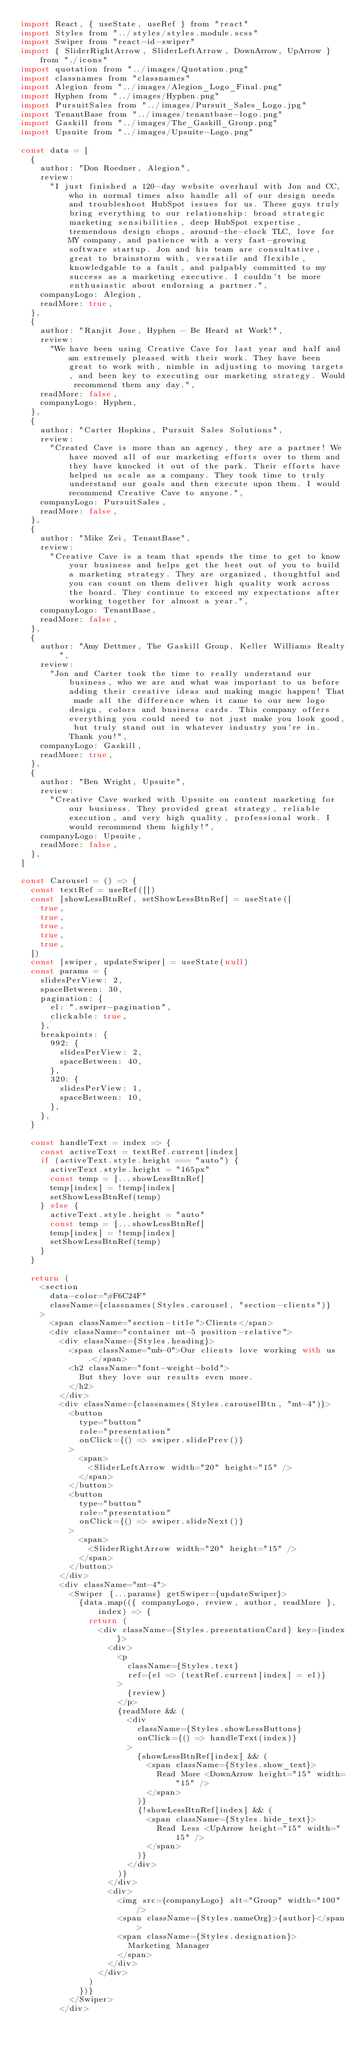<code> <loc_0><loc_0><loc_500><loc_500><_JavaScript_>import React, { useState, useRef } from "react"
import Styles from "../styles/styles.module.scss"
import Swiper from "react-id-swiper"
import { SliderRightArrow, SliderLeftArrow, DownArrow, UpArrow } from "./icons"
import quotation from "../images/Quotation.png"
import classnames from "classnames"
import Alegion from "../images/Alegion_Logo_Final.png"
import Hyphen from "../images/Hyphen.png"
import PursuitSales from "../images/Pursuit_Sales_Logo.jpg"
import TenantBase from "../images/tenantbase-logo.png"
import Gaskill from "../images/The_Gaskill_Group.png"
import Upsuite from "../images/Upsuite-Logo.png"

const data = [
  {
    author: "Don Roedner, Alegion",
    review:
      "I just finished a 120-day website overhaul with Jon and CC, who in normal times also handle all of our design needs and troubleshoot HubSpot issues for us. These guys truly bring everything to our relationship: broad strategic marketing sensibilities, deep HubSpot expertise, tremendous design chops, around-the-clock TLC, love for MY company, and patience with a very fast-growing software startup. Jon and his team are consultative, great to brainstorm with, versatile and flexible, knowledgable to a fault, and palpably committed to my success as a marketing executive. I couldn't be more enthusiastic about endorsing a partner.",
    companyLogo: Alegion,
    readMore: true,
  },
  {
    author: "Ranjit Jose, Hyphen - Be Heard at Work!",
    review:
      "We have been using Creative Cave for last year and half and am extremely pleased with their work. They have been great to work with, nimble in adjusting to moving targets, and been key to executing our marketing strategy. Would recommend them any day.",
    readMore: false,
    companyLogo: Hyphen,
  },
  {
    author: "Carter Hopkins, Pursuit Sales Solutions",
    review:
      "Created Cave is more than an agency, they are a partner! We have moved all of our marketing efforts over to them and they have knocked it out of the park. Their efforts have helped us scale as a company. They took time to truly understand our goals and then execute upon them. I would recommend Creative Cave to anyone.",
    companyLogo: PursuitSales,
    readMore: false,
  },
  {
    author: "Mike Zei, TenantBase",
    review:
      "Creative Cave is a team that spends the time to get to know your business and helps get the best out of you to build a marketing strategy. They are organized, thoughtful and you can count on them deliver high quality work across the board. They continue to exceed my expectations after working together for almost a year.",
    companyLogo: TenantBase,
    readMore: false,
  },
  {
    author: "Amy Dettmer, The Gaskill Group, Keller Williams Realty",
    review:
      "Jon and Carter took the time to really understand our business, who we are and what was important to us before adding their creative ideas and making magic happen! That made all the difference when it came to our new logo design, colors and business cards. This company offers everything you could need to not just make you look good, but truly stand out in whatever industry you're in. Thank you!",
    companyLogo: Gaskill,
    readMore: true,
  },
  {
    author: "Ben Wright, Upsuite",
    review:
      "Creative Cave worked with Upsuite on content marketing for our business. They provided great strategy, reliable execution, and very high quality, professional work. I would recommend them highly!",
    companyLogo: Upsuite,
    readMore: false,
  },
]

const Carousel = () => {
  const textRef = useRef([])
  const [showLessBtnRef, setShowLessBtnRef] = useState([
    true,
    true,
    true,
    true,
    true,
  ])
  const [swiper, updateSwiper] = useState(null)
  const params = {
    slidesPerView: 2,
    spaceBetween: 30,
    pagination: {
      el: ".swiper-pagination",
      clickable: true,
    },
    breakpoints: {
      992: {
        slidesPerView: 2,
        spaceBetween: 40,
      },
      320: {
        slidesPerView: 1,
        spaceBetween: 10,
      },
    },
  }

  const handleText = index => {
    const activeText = textRef.current[index]
    if (activeText.style.height === "auto") {
      activeText.style.height = "165px"
      const temp = [...showLessBtnRef]
      temp[index] = !temp[index]
      setShowLessBtnRef(temp)
    } else {
      activeText.style.height = "auto"
      const temp = [...showLessBtnRef]
      temp[index] = !temp[index]
      setShowLessBtnRef(temp)
    }
  }

  return (
    <section
      data-color="#F6C24F"
      className={classnames(Styles.carousel, "section-clients")}
    >
      <span className="section-title">Clients</span>
      <div className="container mt-5 position-relative">
        <div className={Styles.heading}>
          <span className="mb-0">Our clients love working with us.</span>
          <h2 className="font-weight-bold">
            But they love our results even more.
          </h2>
        </div>
        <div className={classnames(Styles.carouselBtn, "mt-4")}>
          <button
            type="button"
            role="presentation"
            onClick={() => swiper.slidePrev()}
          >
            <span>
              <SliderLeftArrow width="20" height="15" />
            </span>
          </button>
          <button
            type="button"
            role="presentation"
            onClick={() => swiper.slideNext()}
          >
            <span>
              <SliderRightArrow width="20" height="15" />
            </span>
          </button>
        </div>
        <div className="mt-4">
          <Swiper {...params} getSwiper={updateSwiper}>
            {data.map(({ companyLogo, review, author, readMore }, index) => {
              return (
                <div className={Styles.presentationCard} key={index}>
                  <div>
                    <p
                      className={Styles.text}
                      ref={el => (textRef.current[index] = el)}
                    >
                      {review}
                    </p>
                    {readMore && (
                      <div
                        className={Styles.showLessButtons}
                        onClick={() => handleText(index)}
                      >
                        {showLessBtnRef[index] && (
                          <span className={Styles.show_text}>
                            Read More <DownArrow height="15" width="15" />
                          </span>
                        )}
                        {!showLessBtnRef[index] && (
                          <span className={Styles.hide_text}>
                            Read Less <UpArrow height="15" width="15" />
                          </span>
                        )}
                      </div>
                    )}
                  </div>
                  <div>
                    <img src={companyLogo} alt="Group" width="100" />
                    <span className={Styles.nameOrg}>{author}</span>
                    <span className={Styles.designation}>
                      Marketing Manager
                    </span>
                  </div>
                </div>
              )
            })}
          </Swiper>
        </div></code> 